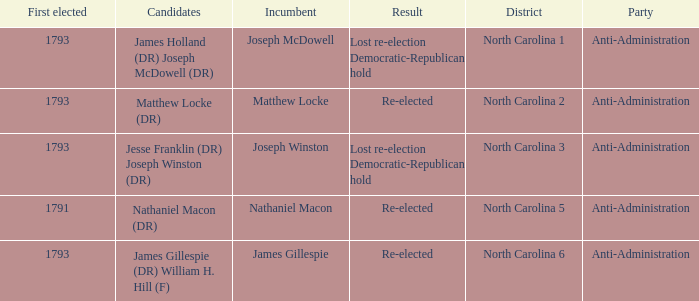Who was the candidate in 1791? Nathaniel Macon (DR). 